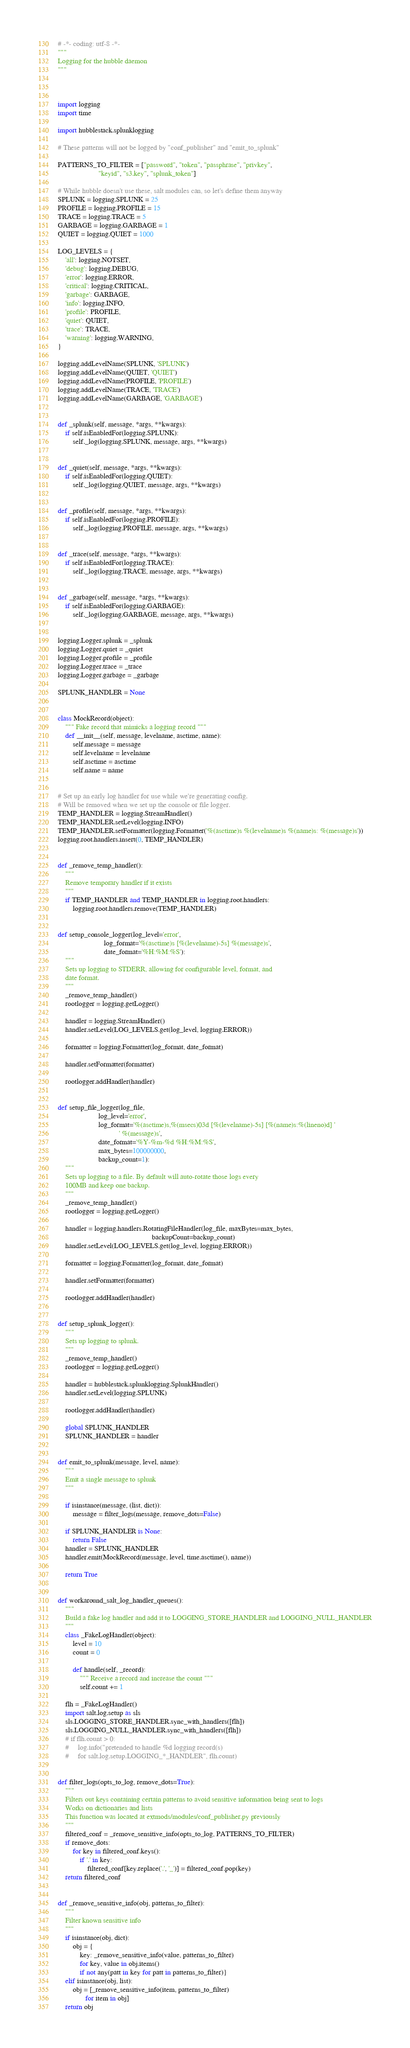<code> <loc_0><loc_0><loc_500><loc_500><_Python_># -*- coding: utf-8 -*-
"""
Logging for the hubble daemon
"""



import logging
import time

import hubblestack.splunklogging

# These patterns will not be logged by "conf_publisher" and "emit_to_splunk"

PATTERNS_TO_FILTER = ["password", "token", "passphrase", "privkey",
                      "keyid", "s3.key", "splunk_token"]

# While hubble doesn't use these, salt modules can, so let's define them anyway
SPLUNK = logging.SPLUNK = 25
PROFILE = logging.PROFILE = 15
TRACE = logging.TRACE = 5
GARBAGE = logging.GARBAGE = 1
QUIET = logging.QUIET = 1000

LOG_LEVELS = {
    'all': logging.NOTSET,
    'debug': logging.DEBUG,
    'error': logging.ERROR,
    'critical': logging.CRITICAL,
    'garbage': GARBAGE,
    'info': logging.INFO,
    'profile': PROFILE,
    'quiet': QUIET,
    'trace': TRACE,
    'warning': logging.WARNING,
}

logging.addLevelName(SPLUNK, 'SPLUNK')
logging.addLevelName(QUIET, 'QUIET')
logging.addLevelName(PROFILE, 'PROFILE')
logging.addLevelName(TRACE, 'TRACE')
logging.addLevelName(GARBAGE, 'GARBAGE')


def _splunk(self, message, *args, **kwargs):
    if self.isEnabledFor(logging.SPLUNK):
        self._log(logging.SPLUNK, message, args, **kwargs)


def _quiet(self, message, *args, **kwargs):
    if self.isEnabledFor(logging.QUIET):
        self._log(logging.QUIET, message, args, **kwargs)


def _profile(self, message, *args, **kwargs):
    if self.isEnabledFor(logging.PROFILE):
        self._log(logging.PROFILE, message, args, **kwargs)


def _trace(self, message, *args, **kwargs):
    if self.isEnabledFor(logging.TRACE):
        self._log(logging.TRACE, message, args, **kwargs)


def _garbage(self, message, *args, **kwargs):
    if self.isEnabledFor(logging.GARBAGE):
        self._log(logging.GARBAGE, message, args, **kwargs)


logging.Logger.splunk = _splunk
logging.Logger.quiet = _quiet
logging.Logger.profile = _profile
logging.Logger.trace = _trace
logging.Logger.garbage = _garbage

SPLUNK_HANDLER = None


class MockRecord(object):
    """ Fake record that mimicks a logging record """
    def __init__(self, message, levelname, asctime, name):
        self.message = message
        self.levelname = levelname
        self.asctime = asctime
        self.name = name


# Set up an early log handler for use while we're generating config.
# Will be removed when we set up the console or file logger.
TEMP_HANDLER = logging.StreamHandler()
TEMP_HANDLER.setLevel(logging.INFO)
TEMP_HANDLER.setFormatter(logging.Formatter('%(asctime)s %(levelname)s %(name)s: %(message)s'))
logging.root.handlers.insert(0, TEMP_HANDLER)


def _remove_temp_handler():
    """
    Remove temporary handler if it exists
    """
    if TEMP_HANDLER and TEMP_HANDLER in logging.root.handlers:
        logging.root.handlers.remove(TEMP_HANDLER)


def setup_console_logger(log_level='error',
                         log_format='%(asctime)s [%(levelname)-5s] %(message)s',
                         date_format='%H:%M:%S'):
    """
    Sets up logging to STDERR, allowing for configurable level, format, and
    date format.
    """
    _remove_temp_handler()
    rootlogger = logging.getLogger()

    handler = logging.StreamHandler()
    handler.setLevel(LOG_LEVELS.get(log_level, logging.ERROR))

    formatter = logging.Formatter(log_format, date_format)

    handler.setFormatter(formatter)

    rootlogger.addHandler(handler)


def setup_file_logger(log_file,
                      log_level='error',
                      log_format='%(asctime)s,%(msecs)03d [%(levelname)-5s] [%(name)s:%(lineno)d] '
                                 ' %(message)s',
                      date_format='%Y-%m-%d %H:%M:%S',
                      max_bytes=100000000,
                      backup_count=1):
    """
    Sets up logging to a file. By default will auto-rotate those logs every
    100MB and keep one backup.
    """
    _remove_temp_handler()
    rootlogger = logging.getLogger()

    handler = logging.handlers.RotatingFileHandler(log_file, maxBytes=max_bytes,
                                                   backupCount=backup_count)
    handler.setLevel(LOG_LEVELS.get(log_level, logging.ERROR))

    formatter = logging.Formatter(log_format, date_format)

    handler.setFormatter(formatter)

    rootlogger.addHandler(handler)


def setup_splunk_logger():
    """
    Sets up logging to splunk.
    """
    _remove_temp_handler()
    rootlogger = logging.getLogger()

    handler = hubblestack.splunklogging.SplunkHandler()
    handler.setLevel(logging.SPLUNK)

    rootlogger.addHandler(handler)

    global SPLUNK_HANDLER
    SPLUNK_HANDLER = handler


def emit_to_splunk(message, level, name):
    """
    Emit a single message to splunk
    """

    if isinstance(message, (list, dict)):
        message = filter_logs(message, remove_dots=False)

    if SPLUNK_HANDLER is None:
        return False
    handler = SPLUNK_HANDLER
    handler.emit(MockRecord(message, level, time.asctime(), name))

    return True


def workaround_salt_log_handler_queues():
    """
    Build a fake log handler and add it to LOGGING_STORE_HANDLER and LOGGING_NULL_HANDLER
    """
    class _FakeLogHandler(object):
        level = 10
        count = 0

        def handle(self, _record):
            """ Receive a record and increase the count """
            self.count += 1

    flh = _FakeLogHandler()
    import salt.log.setup as sls
    sls.LOGGING_STORE_HANDLER.sync_with_handlers([flh])
    sls.LOGGING_NULL_HANDLER.sync_with_handlers([flh])
    # if flh.count > 0:
    #     log.info("pretended to handle %d logging record(s)
    #     for salt.log.setup.LOGGING_*_HANDLER", flh.count)


def filter_logs(opts_to_log, remove_dots=True):
    """
    Filters out keys containing certain patterns to avoid sensitive information being sent to logs
    Works on dictionaries and lists
    This function was located at extmods/modules/conf_publisher.py previously
    """
    filtered_conf = _remove_sensitive_info(opts_to_log, PATTERNS_TO_FILTER)
    if remove_dots:
        for key in filtered_conf.keys():
            if '.' in key:
                filtered_conf[key.replace('.', '_')] = filtered_conf.pop(key)
    return filtered_conf


def _remove_sensitive_info(obj, patterns_to_filter):
    """
    Filter known sensitive info
    """
    if isinstance(obj, dict):
        obj = {
            key: _remove_sensitive_info(value, patterns_to_filter)
            for key, value in obj.items()
            if not any(patt in key for patt in patterns_to_filter)}
    elif isinstance(obj, list):
        obj = [_remove_sensitive_info(item, patterns_to_filter)
               for item in obj]
    return obj
</code> 